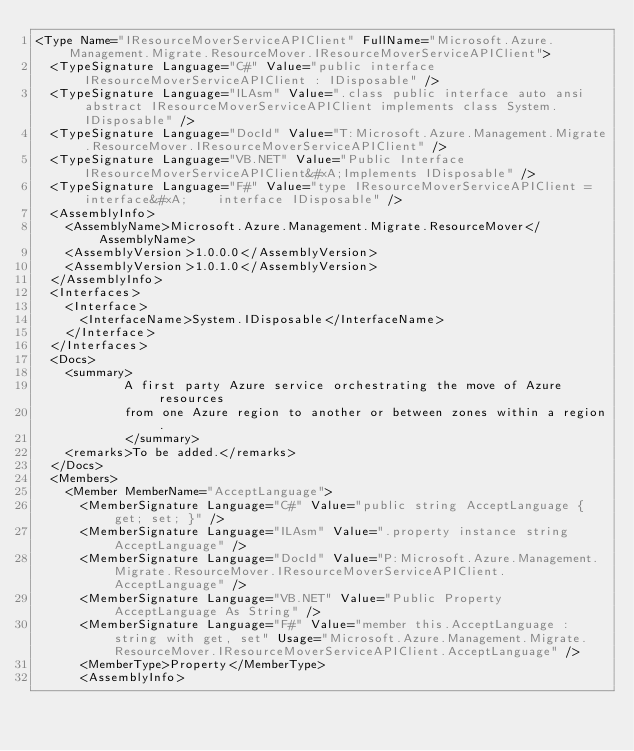Convert code to text. <code><loc_0><loc_0><loc_500><loc_500><_XML_><Type Name="IResourceMoverServiceAPIClient" FullName="Microsoft.Azure.Management.Migrate.ResourceMover.IResourceMoverServiceAPIClient">
  <TypeSignature Language="C#" Value="public interface IResourceMoverServiceAPIClient : IDisposable" />
  <TypeSignature Language="ILAsm" Value=".class public interface auto ansi abstract IResourceMoverServiceAPIClient implements class System.IDisposable" />
  <TypeSignature Language="DocId" Value="T:Microsoft.Azure.Management.Migrate.ResourceMover.IResourceMoverServiceAPIClient" />
  <TypeSignature Language="VB.NET" Value="Public Interface IResourceMoverServiceAPIClient&#xA;Implements IDisposable" />
  <TypeSignature Language="F#" Value="type IResourceMoverServiceAPIClient = interface&#xA;    interface IDisposable" />
  <AssemblyInfo>
    <AssemblyName>Microsoft.Azure.Management.Migrate.ResourceMover</AssemblyName>
    <AssemblyVersion>1.0.0.0</AssemblyVersion>
    <AssemblyVersion>1.0.1.0</AssemblyVersion>
  </AssemblyInfo>
  <Interfaces>
    <Interface>
      <InterfaceName>System.IDisposable</InterfaceName>
    </Interface>
  </Interfaces>
  <Docs>
    <summary>
            A first party Azure service orchestrating the move of Azure resources
            from one Azure region to another or between zones within a region.
            </summary>
    <remarks>To be added.</remarks>
  </Docs>
  <Members>
    <Member MemberName="AcceptLanguage">
      <MemberSignature Language="C#" Value="public string AcceptLanguage { get; set; }" />
      <MemberSignature Language="ILAsm" Value=".property instance string AcceptLanguage" />
      <MemberSignature Language="DocId" Value="P:Microsoft.Azure.Management.Migrate.ResourceMover.IResourceMoverServiceAPIClient.AcceptLanguage" />
      <MemberSignature Language="VB.NET" Value="Public Property AcceptLanguage As String" />
      <MemberSignature Language="F#" Value="member this.AcceptLanguage : string with get, set" Usage="Microsoft.Azure.Management.Migrate.ResourceMover.IResourceMoverServiceAPIClient.AcceptLanguage" />
      <MemberType>Property</MemberType>
      <AssemblyInfo></code> 